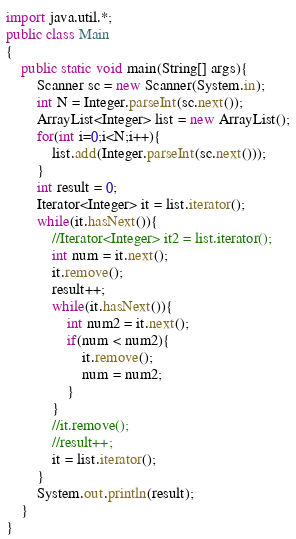Convert code to text. <code><loc_0><loc_0><loc_500><loc_500><_Java_>import java.util.*;
public class Main
{
    public static void main(String[] args){
        Scanner sc = new Scanner(System.in);
        int N = Integer.parseInt(sc.next());
        ArrayList<Integer> list = new ArrayList();
        for(int i=0;i<N;i++){
            list.add(Integer.parseInt(sc.next()));
        }
        int result = 0;
        Iterator<Integer> it = list.iterator();
        while(it.hasNext()){
            //Iterator<Integer> it2 = list.iterator();
            int num = it.next();
            it.remove();
            result++;
            while(it.hasNext()){
                int num2 = it.next();
                if(num < num2){
                    it.remove();
                    num = num2;
                }
            }
            //it.remove();
            //result++;
            it = list.iterator();
        }
        System.out.println(result);
    }
}</code> 